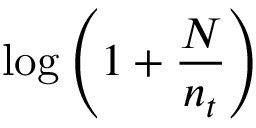Convert formula to latex. <formula><loc_0><loc_0><loc_500><loc_500>\log \left ( 1 + { \frac { N } { n _ { t } } } \right )</formula> 